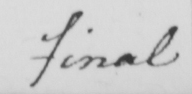Transcribe the text shown in this historical manuscript line. final 